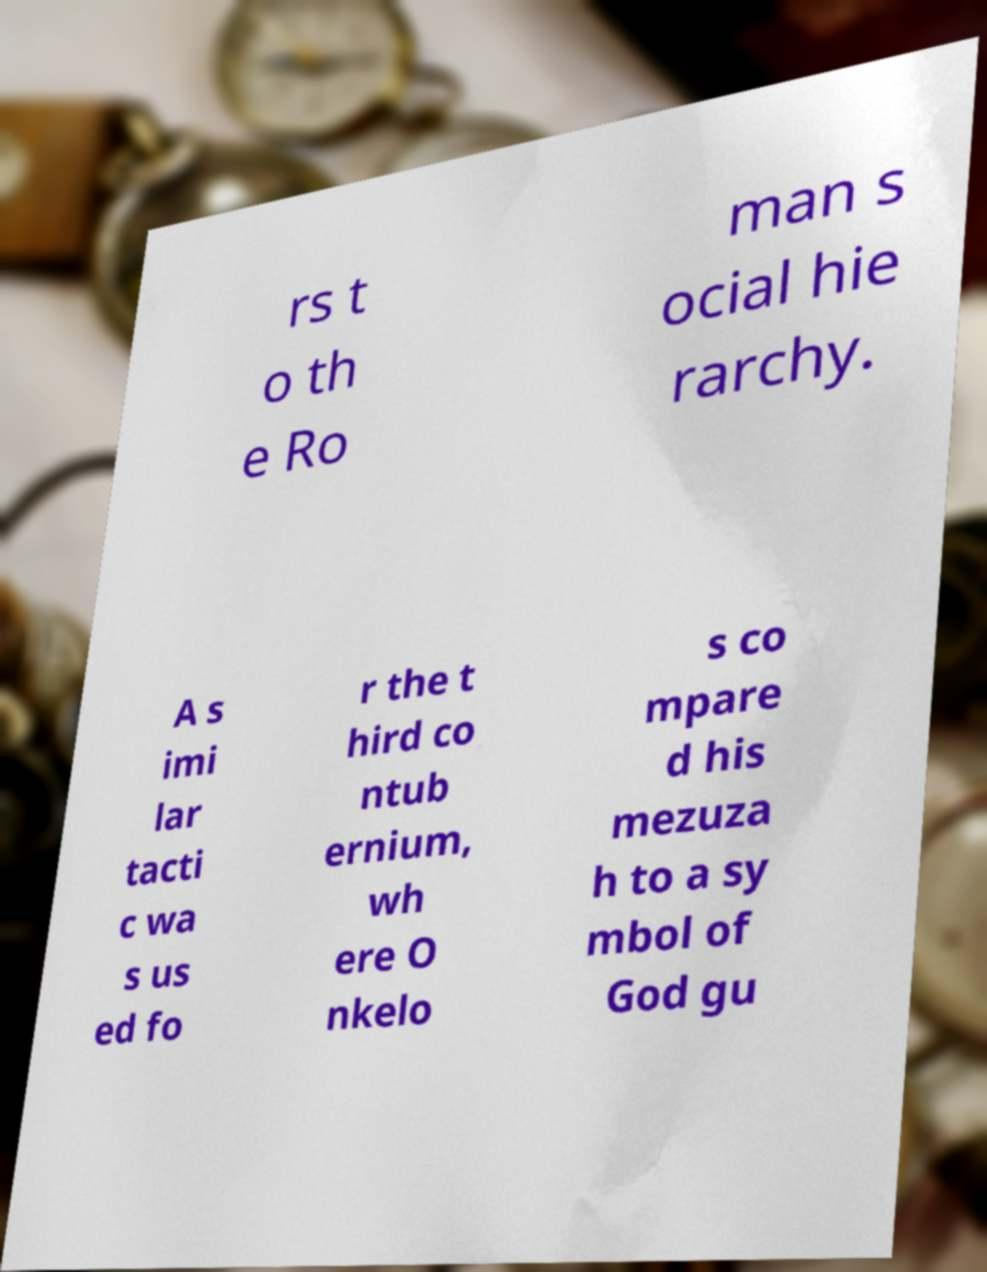There's text embedded in this image that I need extracted. Can you transcribe it verbatim? rs t o th e Ro man s ocial hie rarchy. A s imi lar tacti c wa s us ed fo r the t hird co ntub ernium, wh ere O nkelo s co mpare d his mezuza h to a sy mbol of God gu 